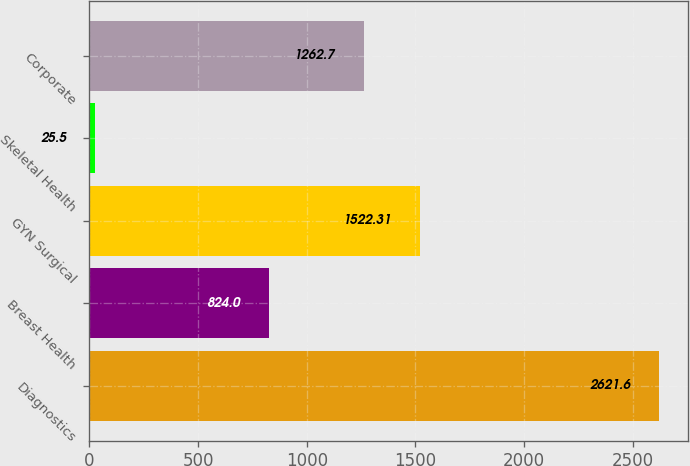<chart> <loc_0><loc_0><loc_500><loc_500><bar_chart><fcel>Diagnostics<fcel>Breast Health<fcel>GYN Surgical<fcel>Skeletal Health<fcel>Corporate<nl><fcel>2621.6<fcel>824<fcel>1522.31<fcel>25.5<fcel>1262.7<nl></chart> 